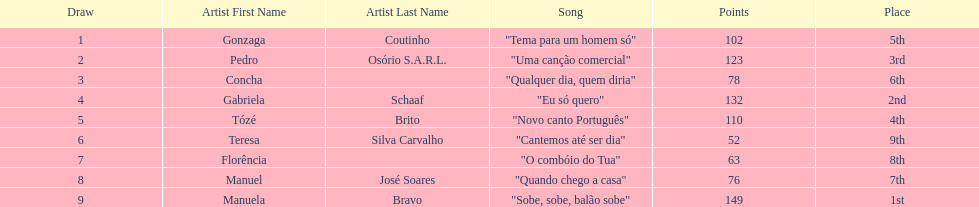What is the total amount of points for florencia? 63. 